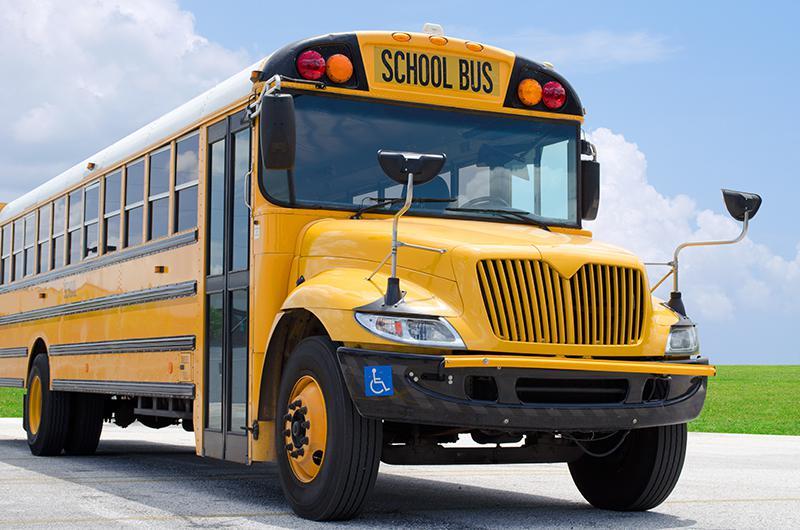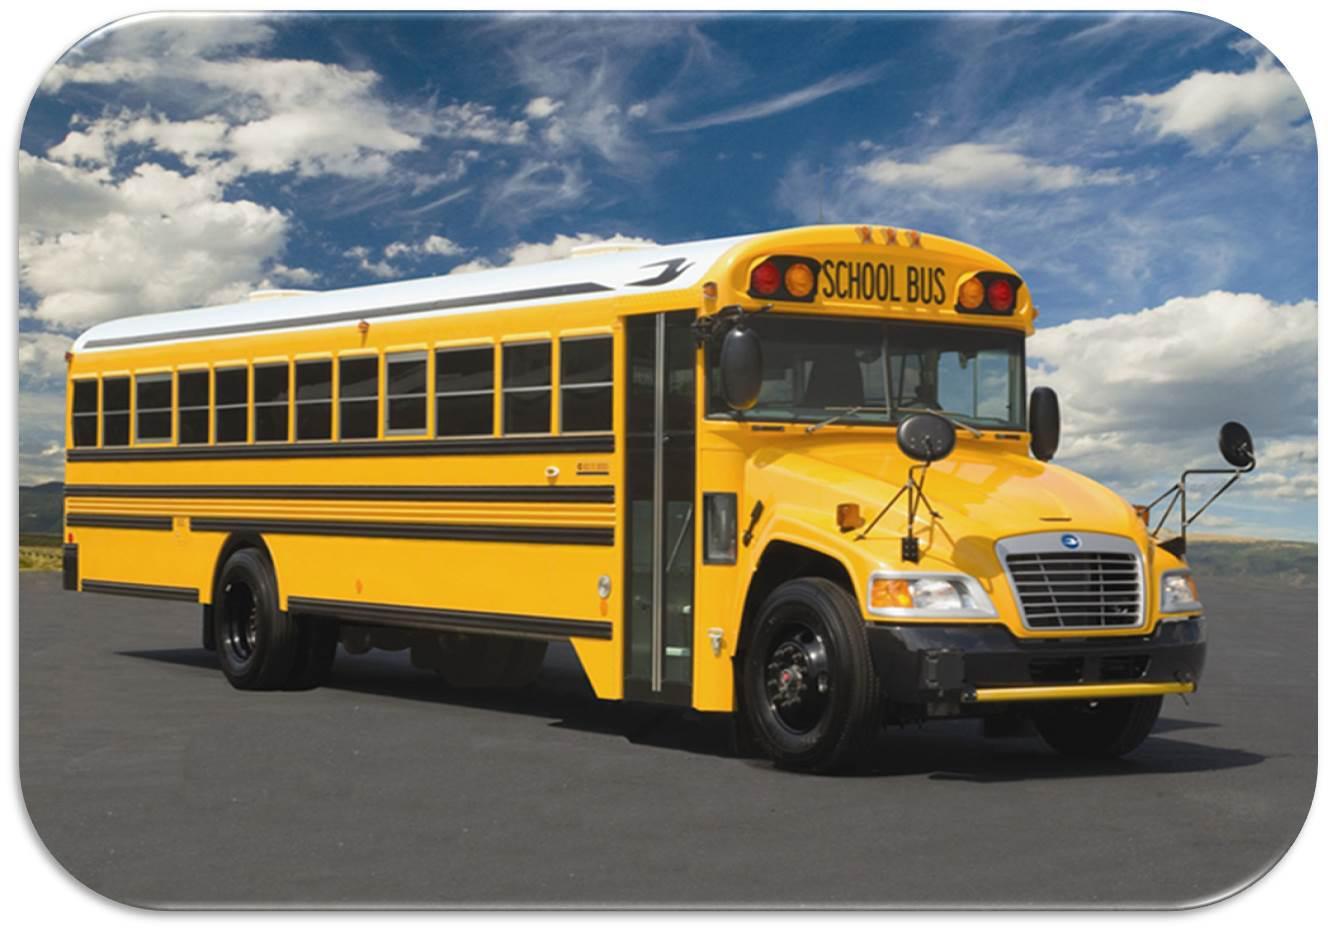The first image is the image on the left, the second image is the image on the right. Considering the images on both sides, is "The right image contains a school bus that is facing towards the right." valid? Answer yes or no. Yes. The first image is the image on the left, the second image is the image on the right. Assess this claim about the two images: "All school buses are intact and angled heading rightward, with no buildings visible behind them.". Correct or not? Answer yes or no. Yes. 